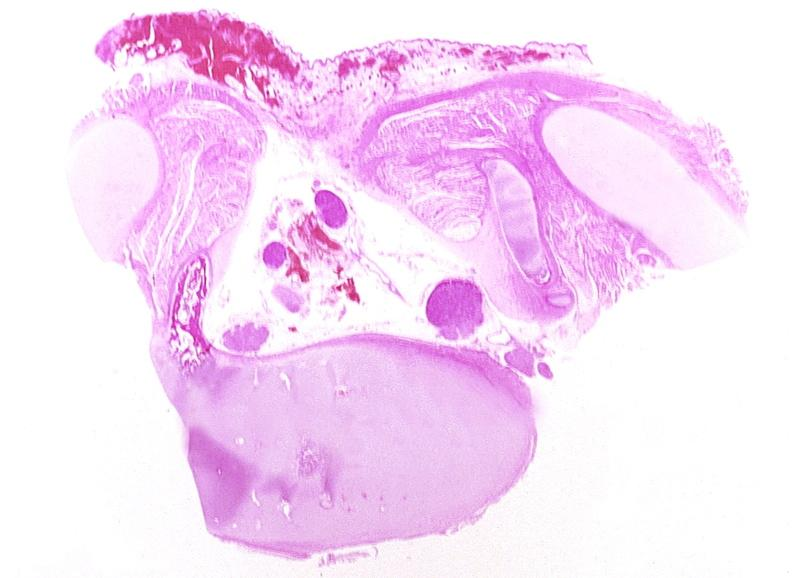what does this image show?
Answer the question using a single word or phrase. Neural tube defect 